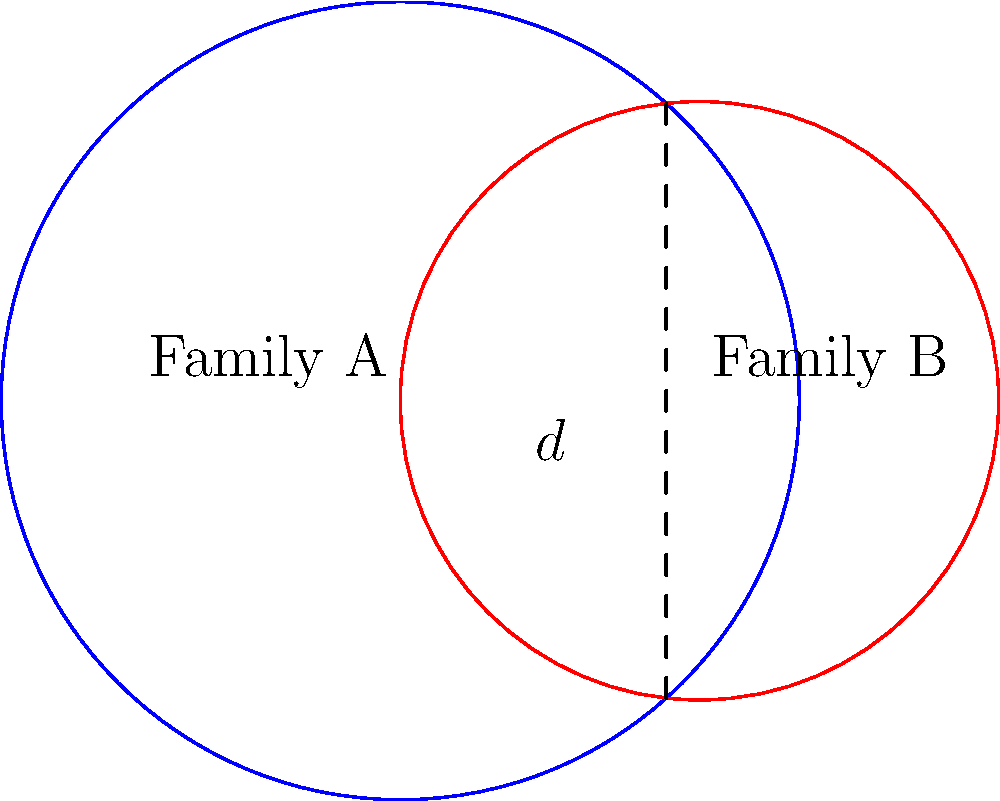In a cold case investigation, you're analyzing two circular family trees represented by intersecting circles. Family A's tree has a radius of 4 units, while Family B's tree has a radius of 3 units. The centers of these circles are 3 units apart. Calculate the area of overlap between these two family trees, which could potentially contain shared DNA profiles crucial for identifying victims. Round your answer to two decimal places. To find the area of overlap between two circles, we can use the formula for the area of intersection:

$$A = r_1^2 \arccos(\frac{d^2 + r_1^2 - r_2^2}{2dr_1}) + r_2^2 \arccos(\frac{d^2 + r_2^2 - r_1^2}{2dr_2}) - \frac{1}{2}\sqrt{(-d+r_1+r_2)(d+r_1-r_2)(d-r_1+r_2)(d+r_1+r_2)}$$

Where:
$r_1 = 4$ (radius of Family A's tree)
$r_2 = 3$ (radius of Family B's tree)
$d = 3$ (distance between centers)

Step 1: Calculate the first term
$$4^2 \arccos(\frac{3^2 + 4^2 - 3^2}{2 \cdot 3 \cdot 4}) = 16 \arccos(\frac{25}{24}) = 16 \cdot 0.2534 = 4.0544$$

Step 2: Calculate the second term
$$3^2 \arccos(\frac{3^2 + 3^2 - 4^2}{2 \cdot 3 \cdot 3}) = 9 \arccos(\frac{2}{9}) = 9 \cdot 1.3694 = 12.3246$$

Step 3: Calculate the third term
$$\frac{1}{2}\sqrt{(-3+4+3)(3+4-3)(3-4+3)(3+4+3)} = \frac{1}{2}\sqrt{4 \cdot 4 \cdot 2 \cdot 10} = \frac{1}{2}\sqrt{320} = 8.9443$$

Step 4: Sum up the terms
$$A = 4.0544 + 12.3246 - 8.9443 = 7.4347$$

Step 5: Round to two decimal places
$$A \approx 7.43$$
Answer: 7.43 square units 